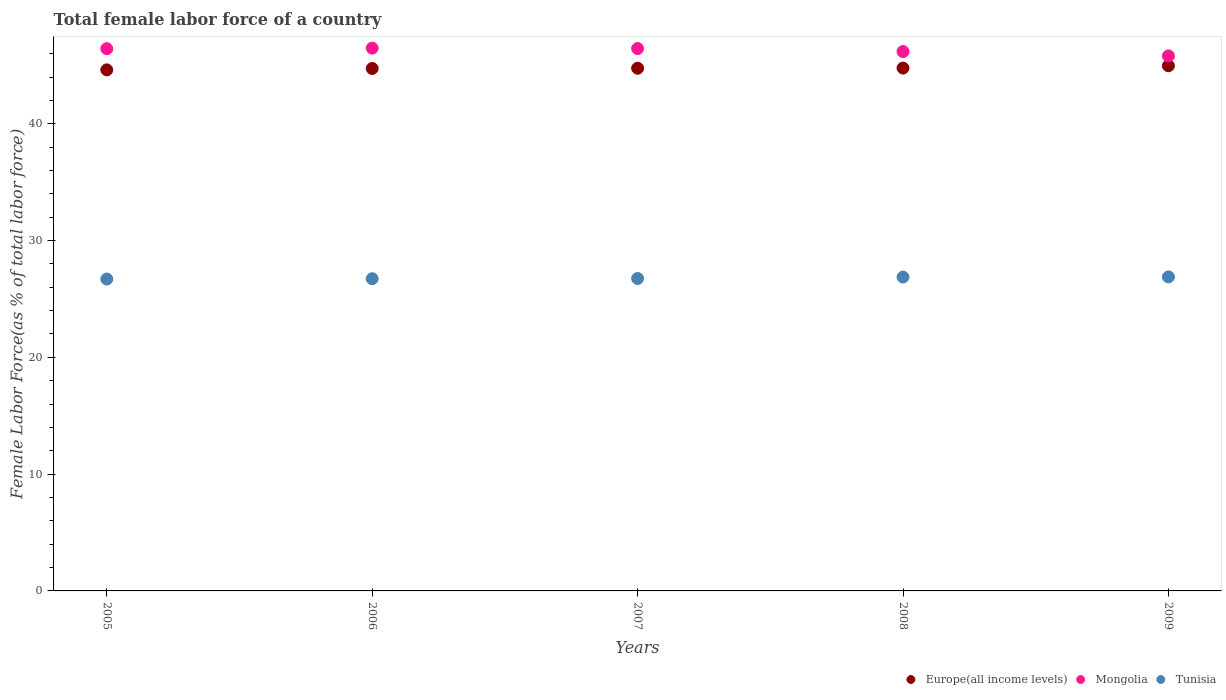What is the percentage of female labor force in Europe(all income levels) in 2006?
Your answer should be compact. 44.73. Across all years, what is the maximum percentage of female labor force in Mongolia?
Offer a terse response. 46.48. Across all years, what is the minimum percentage of female labor force in Mongolia?
Ensure brevity in your answer.  45.81. In which year was the percentage of female labor force in Tunisia maximum?
Ensure brevity in your answer.  2009. In which year was the percentage of female labor force in Europe(all income levels) minimum?
Give a very brief answer. 2005. What is the total percentage of female labor force in Europe(all income levels) in the graph?
Keep it short and to the point. 223.84. What is the difference between the percentage of female labor force in Europe(all income levels) in 2005 and that in 2008?
Your answer should be very brief. -0.15. What is the difference between the percentage of female labor force in Europe(all income levels) in 2009 and the percentage of female labor force in Mongolia in 2007?
Provide a short and direct response. -1.47. What is the average percentage of female labor force in Mongolia per year?
Your response must be concise. 46.27. In the year 2007, what is the difference between the percentage of female labor force in Mongolia and percentage of female labor force in Europe(all income levels)?
Give a very brief answer. 1.69. In how many years, is the percentage of female labor force in Europe(all income levels) greater than 42 %?
Make the answer very short. 5. What is the ratio of the percentage of female labor force in Europe(all income levels) in 2005 to that in 2007?
Offer a very short reply. 1. Is the difference between the percentage of female labor force in Mongolia in 2006 and 2008 greater than the difference between the percentage of female labor force in Europe(all income levels) in 2006 and 2008?
Provide a succinct answer. Yes. What is the difference between the highest and the second highest percentage of female labor force in Europe(all income levels)?
Your answer should be very brief. 0.2. What is the difference between the highest and the lowest percentage of female labor force in Tunisia?
Make the answer very short. 0.18. In how many years, is the percentage of female labor force in Mongolia greater than the average percentage of female labor force in Mongolia taken over all years?
Ensure brevity in your answer.  3. How many dotlines are there?
Keep it short and to the point. 3. How are the legend labels stacked?
Make the answer very short. Horizontal. What is the title of the graph?
Give a very brief answer. Total female labor force of a country. What is the label or title of the X-axis?
Ensure brevity in your answer.  Years. What is the label or title of the Y-axis?
Your answer should be very brief. Female Labor Force(as % of total labor force). What is the Female Labor Force(as % of total labor force) of Europe(all income levels) in 2005?
Offer a very short reply. 44.62. What is the Female Labor Force(as % of total labor force) in Mongolia in 2005?
Offer a terse response. 46.43. What is the Female Labor Force(as % of total labor force) in Tunisia in 2005?
Provide a succinct answer. 26.71. What is the Female Labor Force(as % of total labor force) in Europe(all income levels) in 2006?
Provide a short and direct response. 44.73. What is the Female Labor Force(as % of total labor force) in Mongolia in 2006?
Make the answer very short. 46.48. What is the Female Labor Force(as % of total labor force) in Tunisia in 2006?
Offer a terse response. 26.73. What is the Female Labor Force(as % of total labor force) of Europe(all income levels) in 2007?
Offer a very short reply. 44.75. What is the Female Labor Force(as % of total labor force) of Mongolia in 2007?
Your answer should be very brief. 46.44. What is the Female Labor Force(as % of total labor force) of Tunisia in 2007?
Provide a short and direct response. 26.75. What is the Female Labor Force(as % of total labor force) of Europe(all income levels) in 2008?
Your answer should be compact. 44.77. What is the Female Labor Force(as % of total labor force) in Mongolia in 2008?
Make the answer very short. 46.18. What is the Female Labor Force(as % of total labor force) in Tunisia in 2008?
Your answer should be very brief. 26.88. What is the Female Labor Force(as % of total labor force) in Europe(all income levels) in 2009?
Your answer should be compact. 44.97. What is the Female Labor Force(as % of total labor force) of Mongolia in 2009?
Ensure brevity in your answer.  45.81. What is the Female Labor Force(as % of total labor force) in Tunisia in 2009?
Your response must be concise. 26.89. Across all years, what is the maximum Female Labor Force(as % of total labor force) of Europe(all income levels)?
Your answer should be very brief. 44.97. Across all years, what is the maximum Female Labor Force(as % of total labor force) in Mongolia?
Provide a succinct answer. 46.48. Across all years, what is the maximum Female Labor Force(as % of total labor force) of Tunisia?
Make the answer very short. 26.89. Across all years, what is the minimum Female Labor Force(as % of total labor force) of Europe(all income levels)?
Your response must be concise. 44.62. Across all years, what is the minimum Female Labor Force(as % of total labor force) in Mongolia?
Give a very brief answer. 45.81. Across all years, what is the minimum Female Labor Force(as % of total labor force) of Tunisia?
Offer a very short reply. 26.71. What is the total Female Labor Force(as % of total labor force) in Europe(all income levels) in the graph?
Keep it short and to the point. 223.84. What is the total Female Labor Force(as % of total labor force) of Mongolia in the graph?
Offer a very short reply. 231.34. What is the total Female Labor Force(as % of total labor force) in Tunisia in the graph?
Your response must be concise. 133.96. What is the difference between the Female Labor Force(as % of total labor force) in Europe(all income levels) in 2005 and that in 2006?
Offer a very short reply. -0.12. What is the difference between the Female Labor Force(as % of total labor force) in Mongolia in 2005 and that in 2006?
Provide a short and direct response. -0.05. What is the difference between the Female Labor Force(as % of total labor force) of Tunisia in 2005 and that in 2006?
Your response must be concise. -0.03. What is the difference between the Female Labor Force(as % of total labor force) of Europe(all income levels) in 2005 and that in 2007?
Give a very brief answer. -0.14. What is the difference between the Female Labor Force(as % of total labor force) of Mongolia in 2005 and that in 2007?
Offer a terse response. -0.01. What is the difference between the Female Labor Force(as % of total labor force) of Tunisia in 2005 and that in 2007?
Provide a succinct answer. -0.05. What is the difference between the Female Labor Force(as % of total labor force) in Europe(all income levels) in 2005 and that in 2008?
Provide a short and direct response. -0.15. What is the difference between the Female Labor Force(as % of total labor force) in Mongolia in 2005 and that in 2008?
Keep it short and to the point. 0.25. What is the difference between the Female Labor Force(as % of total labor force) of Tunisia in 2005 and that in 2008?
Your answer should be compact. -0.17. What is the difference between the Female Labor Force(as % of total labor force) in Europe(all income levels) in 2005 and that in 2009?
Offer a terse response. -0.35. What is the difference between the Female Labor Force(as % of total labor force) in Mongolia in 2005 and that in 2009?
Ensure brevity in your answer.  0.62. What is the difference between the Female Labor Force(as % of total labor force) of Tunisia in 2005 and that in 2009?
Offer a very short reply. -0.18. What is the difference between the Female Labor Force(as % of total labor force) of Europe(all income levels) in 2006 and that in 2007?
Provide a succinct answer. -0.02. What is the difference between the Female Labor Force(as % of total labor force) of Mongolia in 2006 and that in 2007?
Make the answer very short. 0.04. What is the difference between the Female Labor Force(as % of total labor force) of Tunisia in 2006 and that in 2007?
Give a very brief answer. -0.02. What is the difference between the Female Labor Force(as % of total labor force) in Europe(all income levels) in 2006 and that in 2008?
Your response must be concise. -0.03. What is the difference between the Female Labor Force(as % of total labor force) of Mongolia in 2006 and that in 2008?
Offer a very short reply. 0.29. What is the difference between the Female Labor Force(as % of total labor force) in Tunisia in 2006 and that in 2008?
Your response must be concise. -0.14. What is the difference between the Female Labor Force(as % of total labor force) of Europe(all income levels) in 2006 and that in 2009?
Offer a very short reply. -0.23. What is the difference between the Female Labor Force(as % of total labor force) of Mongolia in 2006 and that in 2009?
Provide a short and direct response. 0.67. What is the difference between the Female Labor Force(as % of total labor force) in Tunisia in 2006 and that in 2009?
Offer a very short reply. -0.16. What is the difference between the Female Labor Force(as % of total labor force) of Europe(all income levels) in 2007 and that in 2008?
Your answer should be very brief. -0.02. What is the difference between the Female Labor Force(as % of total labor force) in Mongolia in 2007 and that in 2008?
Provide a succinct answer. 0.26. What is the difference between the Female Labor Force(as % of total labor force) of Tunisia in 2007 and that in 2008?
Make the answer very short. -0.12. What is the difference between the Female Labor Force(as % of total labor force) in Europe(all income levels) in 2007 and that in 2009?
Make the answer very short. -0.21. What is the difference between the Female Labor Force(as % of total labor force) of Mongolia in 2007 and that in 2009?
Keep it short and to the point. 0.63. What is the difference between the Female Labor Force(as % of total labor force) in Tunisia in 2007 and that in 2009?
Provide a succinct answer. -0.14. What is the difference between the Female Labor Force(as % of total labor force) of Europe(all income levels) in 2008 and that in 2009?
Offer a terse response. -0.2. What is the difference between the Female Labor Force(as % of total labor force) in Mongolia in 2008 and that in 2009?
Offer a terse response. 0.37. What is the difference between the Female Labor Force(as % of total labor force) in Tunisia in 2008 and that in 2009?
Your answer should be compact. -0.01. What is the difference between the Female Labor Force(as % of total labor force) of Europe(all income levels) in 2005 and the Female Labor Force(as % of total labor force) of Mongolia in 2006?
Provide a succinct answer. -1.86. What is the difference between the Female Labor Force(as % of total labor force) in Europe(all income levels) in 2005 and the Female Labor Force(as % of total labor force) in Tunisia in 2006?
Your answer should be very brief. 17.88. What is the difference between the Female Labor Force(as % of total labor force) in Mongolia in 2005 and the Female Labor Force(as % of total labor force) in Tunisia in 2006?
Your answer should be very brief. 19.7. What is the difference between the Female Labor Force(as % of total labor force) in Europe(all income levels) in 2005 and the Female Labor Force(as % of total labor force) in Mongolia in 2007?
Your answer should be compact. -1.83. What is the difference between the Female Labor Force(as % of total labor force) in Europe(all income levels) in 2005 and the Female Labor Force(as % of total labor force) in Tunisia in 2007?
Your answer should be compact. 17.86. What is the difference between the Female Labor Force(as % of total labor force) of Mongolia in 2005 and the Female Labor Force(as % of total labor force) of Tunisia in 2007?
Keep it short and to the point. 19.68. What is the difference between the Female Labor Force(as % of total labor force) in Europe(all income levels) in 2005 and the Female Labor Force(as % of total labor force) in Mongolia in 2008?
Make the answer very short. -1.57. What is the difference between the Female Labor Force(as % of total labor force) in Europe(all income levels) in 2005 and the Female Labor Force(as % of total labor force) in Tunisia in 2008?
Your answer should be compact. 17.74. What is the difference between the Female Labor Force(as % of total labor force) of Mongolia in 2005 and the Female Labor Force(as % of total labor force) of Tunisia in 2008?
Provide a short and direct response. 19.55. What is the difference between the Female Labor Force(as % of total labor force) in Europe(all income levels) in 2005 and the Female Labor Force(as % of total labor force) in Mongolia in 2009?
Provide a short and direct response. -1.19. What is the difference between the Female Labor Force(as % of total labor force) of Europe(all income levels) in 2005 and the Female Labor Force(as % of total labor force) of Tunisia in 2009?
Provide a short and direct response. 17.73. What is the difference between the Female Labor Force(as % of total labor force) in Mongolia in 2005 and the Female Labor Force(as % of total labor force) in Tunisia in 2009?
Offer a terse response. 19.54. What is the difference between the Female Labor Force(as % of total labor force) in Europe(all income levels) in 2006 and the Female Labor Force(as % of total labor force) in Mongolia in 2007?
Your response must be concise. -1.71. What is the difference between the Female Labor Force(as % of total labor force) in Europe(all income levels) in 2006 and the Female Labor Force(as % of total labor force) in Tunisia in 2007?
Your response must be concise. 17.98. What is the difference between the Female Labor Force(as % of total labor force) of Mongolia in 2006 and the Female Labor Force(as % of total labor force) of Tunisia in 2007?
Provide a short and direct response. 19.72. What is the difference between the Female Labor Force(as % of total labor force) in Europe(all income levels) in 2006 and the Female Labor Force(as % of total labor force) in Mongolia in 2008?
Make the answer very short. -1.45. What is the difference between the Female Labor Force(as % of total labor force) of Europe(all income levels) in 2006 and the Female Labor Force(as % of total labor force) of Tunisia in 2008?
Ensure brevity in your answer.  17.86. What is the difference between the Female Labor Force(as % of total labor force) in Mongolia in 2006 and the Female Labor Force(as % of total labor force) in Tunisia in 2008?
Keep it short and to the point. 19.6. What is the difference between the Female Labor Force(as % of total labor force) of Europe(all income levels) in 2006 and the Female Labor Force(as % of total labor force) of Mongolia in 2009?
Provide a succinct answer. -1.08. What is the difference between the Female Labor Force(as % of total labor force) in Europe(all income levels) in 2006 and the Female Labor Force(as % of total labor force) in Tunisia in 2009?
Keep it short and to the point. 17.84. What is the difference between the Female Labor Force(as % of total labor force) of Mongolia in 2006 and the Female Labor Force(as % of total labor force) of Tunisia in 2009?
Make the answer very short. 19.59. What is the difference between the Female Labor Force(as % of total labor force) of Europe(all income levels) in 2007 and the Female Labor Force(as % of total labor force) of Mongolia in 2008?
Make the answer very short. -1.43. What is the difference between the Female Labor Force(as % of total labor force) in Europe(all income levels) in 2007 and the Female Labor Force(as % of total labor force) in Tunisia in 2008?
Provide a succinct answer. 17.88. What is the difference between the Female Labor Force(as % of total labor force) of Mongolia in 2007 and the Female Labor Force(as % of total labor force) of Tunisia in 2008?
Make the answer very short. 19.56. What is the difference between the Female Labor Force(as % of total labor force) in Europe(all income levels) in 2007 and the Female Labor Force(as % of total labor force) in Mongolia in 2009?
Provide a succinct answer. -1.06. What is the difference between the Female Labor Force(as % of total labor force) of Europe(all income levels) in 2007 and the Female Labor Force(as % of total labor force) of Tunisia in 2009?
Provide a succinct answer. 17.86. What is the difference between the Female Labor Force(as % of total labor force) of Mongolia in 2007 and the Female Labor Force(as % of total labor force) of Tunisia in 2009?
Make the answer very short. 19.55. What is the difference between the Female Labor Force(as % of total labor force) of Europe(all income levels) in 2008 and the Female Labor Force(as % of total labor force) of Mongolia in 2009?
Give a very brief answer. -1.04. What is the difference between the Female Labor Force(as % of total labor force) in Europe(all income levels) in 2008 and the Female Labor Force(as % of total labor force) in Tunisia in 2009?
Offer a terse response. 17.88. What is the difference between the Female Labor Force(as % of total labor force) in Mongolia in 2008 and the Female Labor Force(as % of total labor force) in Tunisia in 2009?
Ensure brevity in your answer.  19.3. What is the average Female Labor Force(as % of total labor force) of Europe(all income levels) per year?
Provide a succinct answer. 44.77. What is the average Female Labor Force(as % of total labor force) of Mongolia per year?
Provide a succinct answer. 46.27. What is the average Female Labor Force(as % of total labor force) in Tunisia per year?
Your answer should be very brief. 26.79. In the year 2005, what is the difference between the Female Labor Force(as % of total labor force) in Europe(all income levels) and Female Labor Force(as % of total labor force) in Mongolia?
Provide a succinct answer. -1.81. In the year 2005, what is the difference between the Female Labor Force(as % of total labor force) of Europe(all income levels) and Female Labor Force(as % of total labor force) of Tunisia?
Ensure brevity in your answer.  17.91. In the year 2005, what is the difference between the Female Labor Force(as % of total labor force) of Mongolia and Female Labor Force(as % of total labor force) of Tunisia?
Keep it short and to the point. 19.72. In the year 2006, what is the difference between the Female Labor Force(as % of total labor force) in Europe(all income levels) and Female Labor Force(as % of total labor force) in Mongolia?
Your response must be concise. -1.74. In the year 2006, what is the difference between the Female Labor Force(as % of total labor force) in Europe(all income levels) and Female Labor Force(as % of total labor force) in Tunisia?
Provide a short and direct response. 18. In the year 2006, what is the difference between the Female Labor Force(as % of total labor force) in Mongolia and Female Labor Force(as % of total labor force) in Tunisia?
Your answer should be very brief. 19.74. In the year 2007, what is the difference between the Female Labor Force(as % of total labor force) of Europe(all income levels) and Female Labor Force(as % of total labor force) of Mongolia?
Keep it short and to the point. -1.69. In the year 2007, what is the difference between the Female Labor Force(as % of total labor force) of Europe(all income levels) and Female Labor Force(as % of total labor force) of Tunisia?
Your answer should be very brief. 18. In the year 2007, what is the difference between the Female Labor Force(as % of total labor force) in Mongolia and Female Labor Force(as % of total labor force) in Tunisia?
Ensure brevity in your answer.  19.69. In the year 2008, what is the difference between the Female Labor Force(as % of total labor force) of Europe(all income levels) and Female Labor Force(as % of total labor force) of Mongolia?
Make the answer very short. -1.42. In the year 2008, what is the difference between the Female Labor Force(as % of total labor force) in Europe(all income levels) and Female Labor Force(as % of total labor force) in Tunisia?
Keep it short and to the point. 17.89. In the year 2008, what is the difference between the Female Labor Force(as % of total labor force) in Mongolia and Female Labor Force(as % of total labor force) in Tunisia?
Your answer should be very brief. 19.31. In the year 2009, what is the difference between the Female Labor Force(as % of total labor force) of Europe(all income levels) and Female Labor Force(as % of total labor force) of Mongolia?
Offer a terse response. -0.84. In the year 2009, what is the difference between the Female Labor Force(as % of total labor force) of Europe(all income levels) and Female Labor Force(as % of total labor force) of Tunisia?
Your answer should be compact. 18.08. In the year 2009, what is the difference between the Female Labor Force(as % of total labor force) of Mongolia and Female Labor Force(as % of total labor force) of Tunisia?
Offer a very short reply. 18.92. What is the ratio of the Female Labor Force(as % of total labor force) of Europe(all income levels) in 2005 to that in 2006?
Your answer should be compact. 1. What is the ratio of the Female Labor Force(as % of total labor force) of Mongolia in 2005 to that in 2006?
Provide a succinct answer. 1. What is the ratio of the Female Labor Force(as % of total labor force) in Tunisia in 2005 to that in 2006?
Offer a very short reply. 1. What is the ratio of the Female Labor Force(as % of total labor force) of Tunisia in 2005 to that in 2007?
Give a very brief answer. 1. What is the ratio of the Female Labor Force(as % of total labor force) of Europe(all income levels) in 2005 to that in 2008?
Keep it short and to the point. 1. What is the ratio of the Female Labor Force(as % of total labor force) of Mongolia in 2005 to that in 2008?
Make the answer very short. 1.01. What is the ratio of the Female Labor Force(as % of total labor force) in Mongolia in 2005 to that in 2009?
Offer a terse response. 1.01. What is the ratio of the Female Labor Force(as % of total labor force) in Europe(all income levels) in 2006 to that in 2007?
Give a very brief answer. 1. What is the ratio of the Female Labor Force(as % of total labor force) in Mongolia in 2006 to that in 2007?
Give a very brief answer. 1. What is the ratio of the Female Labor Force(as % of total labor force) in Tunisia in 2006 to that in 2007?
Your answer should be compact. 1. What is the ratio of the Female Labor Force(as % of total labor force) in Mongolia in 2006 to that in 2009?
Keep it short and to the point. 1.01. What is the ratio of the Female Labor Force(as % of total labor force) of Tunisia in 2006 to that in 2009?
Make the answer very short. 0.99. What is the ratio of the Female Labor Force(as % of total labor force) in Tunisia in 2007 to that in 2008?
Offer a very short reply. 1. What is the ratio of the Female Labor Force(as % of total labor force) of Europe(all income levels) in 2007 to that in 2009?
Give a very brief answer. 1. What is the ratio of the Female Labor Force(as % of total labor force) in Mongolia in 2007 to that in 2009?
Ensure brevity in your answer.  1.01. What is the ratio of the Female Labor Force(as % of total labor force) of Tunisia in 2007 to that in 2009?
Make the answer very short. 0.99. What is the ratio of the Female Labor Force(as % of total labor force) in Mongolia in 2008 to that in 2009?
Give a very brief answer. 1.01. What is the difference between the highest and the second highest Female Labor Force(as % of total labor force) in Europe(all income levels)?
Ensure brevity in your answer.  0.2. What is the difference between the highest and the second highest Female Labor Force(as % of total labor force) in Mongolia?
Your answer should be very brief. 0.04. What is the difference between the highest and the second highest Female Labor Force(as % of total labor force) of Tunisia?
Your answer should be very brief. 0.01. What is the difference between the highest and the lowest Female Labor Force(as % of total labor force) in Europe(all income levels)?
Your answer should be very brief. 0.35. What is the difference between the highest and the lowest Female Labor Force(as % of total labor force) of Mongolia?
Provide a succinct answer. 0.67. What is the difference between the highest and the lowest Female Labor Force(as % of total labor force) in Tunisia?
Offer a very short reply. 0.18. 